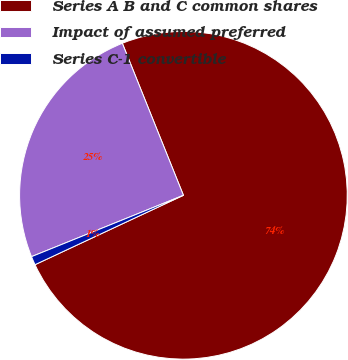Convert chart to OTSL. <chart><loc_0><loc_0><loc_500><loc_500><pie_chart><fcel>Series A B and C common shares<fcel>Impact of assumed preferred<fcel>Series C-1 convertible<nl><fcel>74.12%<fcel>25.03%<fcel>0.85%<nl></chart> 